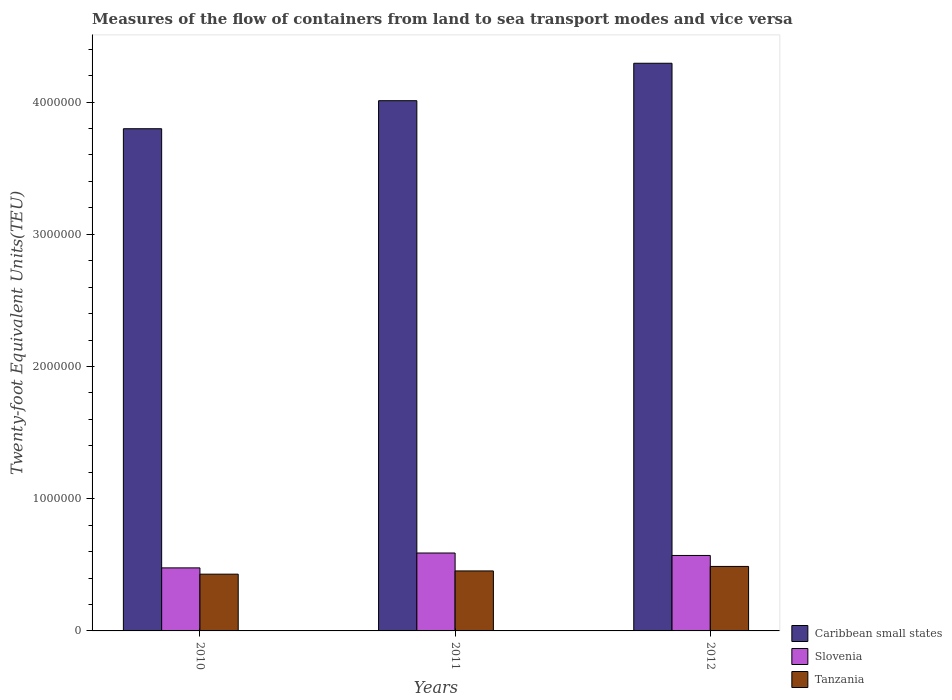Are the number of bars per tick equal to the number of legend labels?
Your response must be concise. Yes. Are the number of bars on each tick of the X-axis equal?
Make the answer very short. Yes. What is the label of the 1st group of bars from the left?
Your response must be concise. 2010. What is the container port traffic in Caribbean small states in 2012?
Give a very brief answer. 4.29e+06. Across all years, what is the maximum container port traffic in Tanzania?
Ensure brevity in your answer.  4.88e+05. Across all years, what is the minimum container port traffic in Slovenia?
Your response must be concise. 4.77e+05. In which year was the container port traffic in Tanzania minimum?
Make the answer very short. 2010. What is the total container port traffic in Slovenia in the graph?
Offer a terse response. 1.64e+06. What is the difference between the container port traffic in Slovenia in 2010 and that in 2012?
Offer a very short reply. -9.40e+04. What is the difference between the container port traffic in Tanzania in 2011 and the container port traffic in Caribbean small states in 2012?
Your answer should be very brief. -3.84e+06. What is the average container port traffic in Caribbean small states per year?
Ensure brevity in your answer.  4.03e+06. In the year 2012, what is the difference between the container port traffic in Caribbean small states and container port traffic in Tanzania?
Provide a short and direct response. 3.81e+06. In how many years, is the container port traffic in Caribbean small states greater than 1400000 TEU?
Give a very brief answer. 3. What is the ratio of the container port traffic in Tanzania in 2010 to that in 2012?
Provide a succinct answer. 0.88. What is the difference between the highest and the second highest container port traffic in Slovenia?
Your answer should be compact. 1.86e+04. What is the difference between the highest and the lowest container port traffic in Slovenia?
Your answer should be very brief. 1.13e+05. What does the 1st bar from the left in 2010 represents?
Your answer should be compact. Caribbean small states. What does the 3rd bar from the right in 2012 represents?
Give a very brief answer. Caribbean small states. Is it the case that in every year, the sum of the container port traffic in Tanzania and container port traffic in Caribbean small states is greater than the container port traffic in Slovenia?
Your response must be concise. Yes. How many bars are there?
Your answer should be compact. 9. Are all the bars in the graph horizontal?
Offer a terse response. No. Are the values on the major ticks of Y-axis written in scientific E-notation?
Keep it short and to the point. No. Does the graph contain any zero values?
Provide a short and direct response. No. Does the graph contain grids?
Your answer should be compact. No. How are the legend labels stacked?
Offer a terse response. Vertical. What is the title of the graph?
Offer a very short reply. Measures of the flow of containers from land to sea transport modes and vice versa. Does "Montenegro" appear as one of the legend labels in the graph?
Make the answer very short. No. What is the label or title of the X-axis?
Your answer should be compact. Years. What is the label or title of the Y-axis?
Ensure brevity in your answer.  Twenty-foot Equivalent Units(TEU). What is the Twenty-foot Equivalent Units(TEU) of Caribbean small states in 2010?
Ensure brevity in your answer.  3.80e+06. What is the Twenty-foot Equivalent Units(TEU) of Slovenia in 2010?
Make the answer very short. 4.77e+05. What is the Twenty-foot Equivalent Units(TEU) of Tanzania in 2010?
Make the answer very short. 4.29e+05. What is the Twenty-foot Equivalent Units(TEU) in Caribbean small states in 2011?
Ensure brevity in your answer.  4.01e+06. What is the Twenty-foot Equivalent Units(TEU) in Slovenia in 2011?
Keep it short and to the point. 5.89e+05. What is the Twenty-foot Equivalent Units(TEU) of Tanzania in 2011?
Your answer should be very brief. 4.54e+05. What is the Twenty-foot Equivalent Units(TEU) of Caribbean small states in 2012?
Provide a short and direct response. 4.29e+06. What is the Twenty-foot Equivalent Units(TEU) of Slovenia in 2012?
Provide a succinct answer. 5.71e+05. What is the Twenty-foot Equivalent Units(TEU) of Tanzania in 2012?
Provide a short and direct response. 4.88e+05. Across all years, what is the maximum Twenty-foot Equivalent Units(TEU) of Caribbean small states?
Offer a terse response. 4.29e+06. Across all years, what is the maximum Twenty-foot Equivalent Units(TEU) in Slovenia?
Keep it short and to the point. 5.89e+05. Across all years, what is the maximum Twenty-foot Equivalent Units(TEU) of Tanzania?
Your answer should be compact. 4.88e+05. Across all years, what is the minimum Twenty-foot Equivalent Units(TEU) of Caribbean small states?
Offer a terse response. 3.80e+06. Across all years, what is the minimum Twenty-foot Equivalent Units(TEU) of Slovenia?
Offer a terse response. 4.77e+05. Across all years, what is the minimum Twenty-foot Equivalent Units(TEU) in Tanzania?
Ensure brevity in your answer.  4.29e+05. What is the total Twenty-foot Equivalent Units(TEU) in Caribbean small states in the graph?
Offer a terse response. 1.21e+07. What is the total Twenty-foot Equivalent Units(TEU) of Slovenia in the graph?
Provide a short and direct response. 1.64e+06. What is the total Twenty-foot Equivalent Units(TEU) of Tanzania in the graph?
Your response must be concise. 1.37e+06. What is the difference between the Twenty-foot Equivalent Units(TEU) of Caribbean small states in 2010 and that in 2011?
Give a very brief answer. -2.12e+05. What is the difference between the Twenty-foot Equivalent Units(TEU) in Slovenia in 2010 and that in 2011?
Your response must be concise. -1.13e+05. What is the difference between the Twenty-foot Equivalent Units(TEU) of Tanzania in 2010 and that in 2011?
Your response must be concise. -2.45e+04. What is the difference between the Twenty-foot Equivalent Units(TEU) in Caribbean small states in 2010 and that in 2012?
Offer a terse response. -4.95e+05. What is the difference between the Twenty-foot Equivalent Units(TEU) of Slovenia in 2010 and that in 2012?
Keep it short and to the point. -9.40e+04. What is the difference between the Twenty-foot Equivalent Units(TEU) of Tanzania in 2010 and that in 2012?
Offer a terse response. -5.85e+04. What is the difference between the Twenty-foot Equivalent Units(TEU) in Caribbean small states in 2011 and that in 2012?
Your answer should be very brief. -2.83e+05. What is the difference between the Twenty-foot Equivalent Units(TEU) in Slovenia in 2011 and that in 2012?
Give a very brief answer. 1.86e+04. What is the difference between the Twenty-foot Equivalent Units(TEU) of Tanzania in 2011 and that in 2012?
Ensure brevity in your answer.  -3.40e+04. What is the difference between the Twenty-foot Equivalent Units(TEU) of Caribbean small states in 2010 and the Twenty-foot Equivalent Units(TEU) of Slovenia in 2011?
Your response must be concise. 3.21e+06. What is the difference between the Twenty-foot Equivalent Units(TEU) in Caribbean small states in 2010 and the Twenty-foot Equivalent Units(TEU) in Tanzania in 2011?
Your answer should be compact. 3.34e+06. What is the difference between the Twenty-foot Equivalent Units(TEU) of Slovenia in 2010 and the Twenty-foot Equivalent Units(TEU) of Tanzania in 2011?
Provide a short and direct response. 2.30e+04. What is the difference between the Twenty-foot Equivalent Units(TEU) of Caribbean small states in 2010 and the Twenty-foot Equivalent Units(TEU) of Slovenia in 2012?
Your response must be concise. 3.23e+06. What is the difference between the Twenty-foot Equivalent Units(TEU) of Caribbean small states in 2010 and the Twenty-foot Equivalent Units(TEU) of Tanzania in 2012?
Provide a short and direct response. 3.31e+06. What is the difference between the Twenty-foot Equivalent Units(TEU) of Slovenia in 2010 and the Twenty-foot Equivalent Units(TEU) of Tanzania in 2012?
Your answer should be compact. -1.11e+04. What is the difference between the Twenty-foot Equivalent Units(TEU) of Caribbean small states in 2011 and the Twenty-foot Equivalent Units(TEU) of Slovenia in 2012?
Your response must be concise. 3.44e+06. What is the difference between the Twenty-foot Equivalent Units(TEU) of Caribbean small states in 2011 and the Twenty-foot Equivalent Units(TEU) of Tanzania in 2012?
Make the answer very short. 3.52e+06. What is the difference between the Twenty-foot Equivalent Units(TEU) of Slovenia in 2011 and the Twenty-foot Equivalent Units(TEU) of Tanzania in 2012?
Your answer should be very brief. 1.02e+05. What is the average Twenty-foot Equivalent Units(TEU) in Caribbean small states per year?
Keep it short and to the point. 4.03e+06. What is the average Twenty-foot Equivalent Units(TEU) of Slovenia per year?
Offer a very short reply. 5.46e+05. What is the average Twenty-foot Equivalent Units(TEU) of Tanzania per year?
Offer a terse response. 4.57e+05. In the year 2010, what is the difference between the Twenty-foot Equivalent Units(TEU) in Caribbean small states and Twenty-foot Equivalent Units(TEU) in Slovenia?
Provide a succinct answer. 3.32e+06. In the year 2010, what is the difference between the Twenty-foot Equivalent Units(TEU) in Caribbean small states and Twenty-foot Equivalent Units(TEU) in Tanzania?
Provide a succinct answer. 3.37e+06. In the year 2010, what is the difference between the Twenty-foot Equivalent Units(TEU) in Slovenia and Twenty-foot Equivalent Units(TEU) in Tanzania?
Provide a short and direct response. 4.74e+04. In the year 2011, what is the difference between the Twenty-foot Equivalent Units(TEU) of Caribbean small states and Twenty-foot Equivalent Units(TEU) of Slovenia?
Your response must be concise. 3.42e+06. In the year 2011, what is the difference between the Twenty-foot Equivalent Units(TEU) in Caribbean small states and Twenty-foot Equivalent Units(TEU) in Tanzania?
Offer a terse response. 3.56e+06. In the year 2011, what is the difference between the Twenty-foot Equivalent Units(TEU) in Slovenia and Twenty-foot Equivalent Units(TEU) in Tanzania?
Your answer should be very brief. 1.36e+05. In the year 2012, what is the difference between the Twenty-foot Equivalent Units(TEU) in Caribbean small states and Twenty-foot Equivalent Units(TEU) in Slovenia?
Offer a very short reply. 3.72e+06. In the year 2012, what is the difference between the Twenty-foot Equivalent Units(TEU) of Caribbean small states and Twenty-foot Equivalent Units(TEU) of Tanzania?
Offer a terse response. 3.81e+06. In the year 2012, what is the difference between the Twenty-foot Equivalent Units(TEU) of Slovenia and Twenty-foot Equivalent Units(TEU) of Tanzania?
Give a very brief answer. 8.30e+04. What is the ratio of the Twenty-foot Equivalent Units(TEU) of Caribbean small states in 2010 to that in 2011?
Your answer should be compact. 0.95. What is the ratio of the Twenty-foot Equivalent Units(TEU) in Slovenia in 2010 to that in 2011?
Provide a short and direct response. 0.81. What is the ratio of the Twenty-foot Equivalent Units(TEU) of Tanzania in 2010 to that in 2011?
Make the answer very short. 0.95. What is the ratio of the Twenty-foot Equivalent Units(TEU) of Caribbean small states in 2010 to that in 2012?
Make the answer very short. 0.88. What is the ratio of the Twenty-foot Equivalent Units(TEU) in Slovenia in 2010 to that in 2012?
Ensure brevity in your answer.  0.84. What is the ratio of the Twenty-foot Equivalent Units(TEU) of Tanzania in 2010 to that in 2012?
Give a very brief answer. 0.88. What is the ratio of the Twenty-foot Equivalent Units(TEU) of Caribbean small states in 2011 to that in 2012?
Make the answer very short. 0.93. What is the ratio of the Twenty-foot Equivalent Units(TEU) in Slovenia in 2011 to that in 2012?
Keep it short and to the point. 1.03. What is the ratio of the Twenty-foot Equivalent Units(TEU) in Tanzania in 2011 to that in 2012?
Make the answer very short. 0.93. What is the difference between the highest and the second highest Twenty-foot Equivalent Units(TEU) in Caribbean small states?
Ensure brevity in your answer.  2.83e+05. What is the difference between the highest and the second highest Twenty-foot Equivalent Units(TEU) in Slovenia?
Keep it short and to the point. 1.86e+04. What is the difference between the highest and the second highest Twenty-foot Equivalent Units(TEU) in Tanzania?
Provide a succinct answer. 3.40e+04. What is the difference between the highest and the lowest Twenty-foot Equivalent Units(TEU) of Caribbean small states?
Provide a short and direct response. 4.95e+05. What is the difference between the highest and the lowest Twenty-foot Equivalent Units(TEU) in Slovenia?
Provide a succinct answer. 1.13e+05. What is the difference between the highest and the lowest Twenty-foot Equivalent Units(TEU) of Tanzania?
Keep it short and to the point. 5.85e+04. 